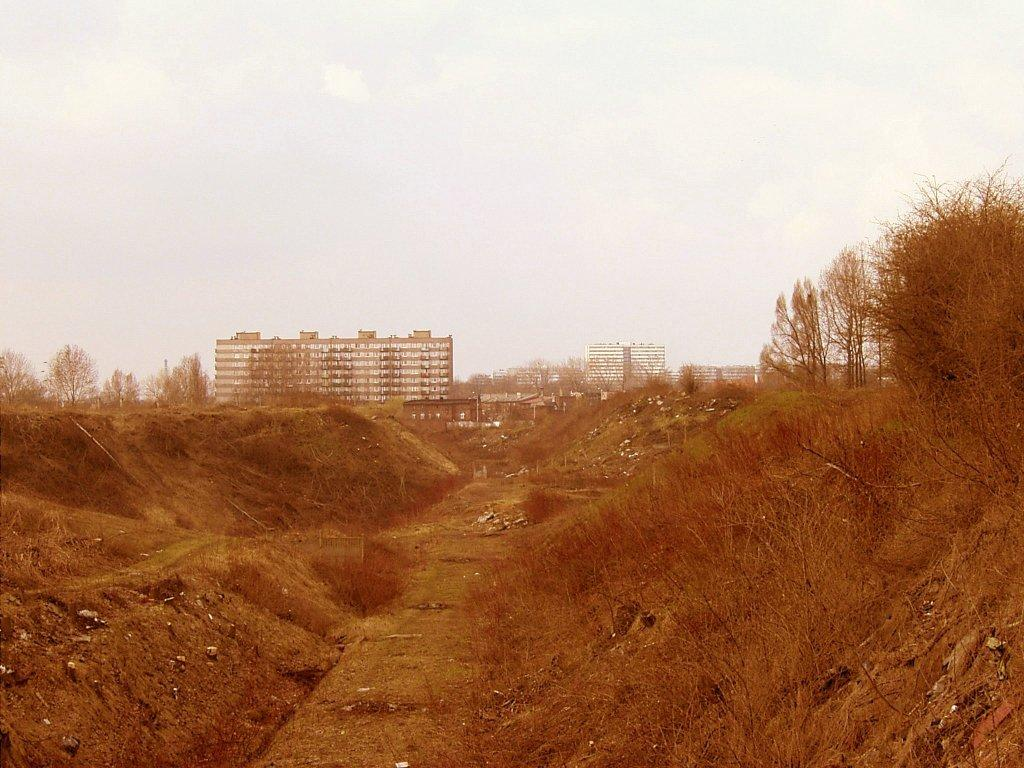What can be seen in the background of the image? In the background of the image, there is a sky, buildings, and trees visible. What type of vegetation is present on the right side of the image? Dried plants are present on the right side of the image. What type of terrain is visible in the image? There is sand visible in the image. What type of boot is being worn by the love interest in the image? There is no person or love interest present in the image, so it is not possible to determine what type of boot they might be wearing. 